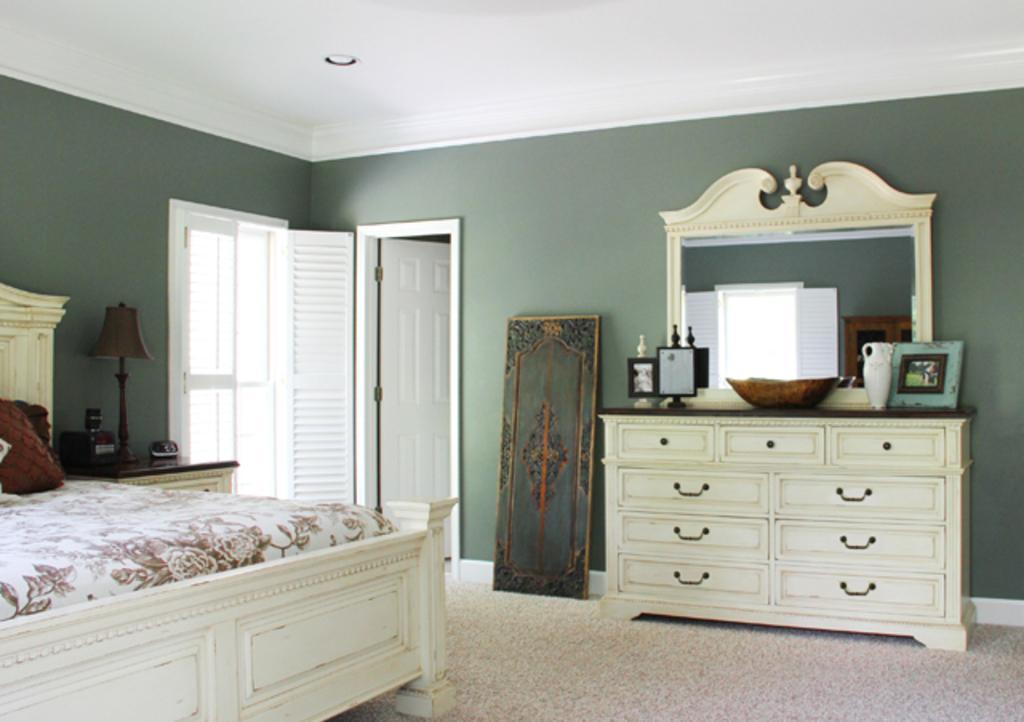Could you give a brief overview of what you see in this image? In this image I can see the bed. In the background I can see the lamp, few cupboards, mirror, doors in white color and the wall is in green color. 